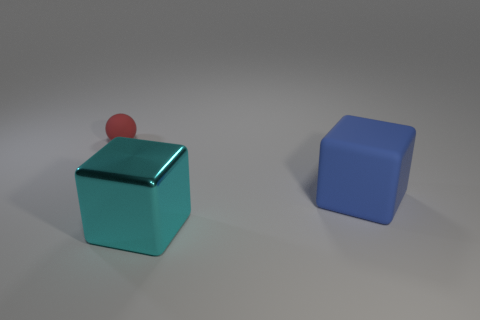Add 2 green matte objects. How many objects exist? 5 Subtract 1 spheres. How many spheres are left? 0 Subtract all balls. How many objects are left? 2 Subtract all yellow cylinders. How many yellow spheres are left? 0 Subtract all big blue matte cubes. Subtract all large cyan rubber things. How many objects are left? 2 Add 2 big cyan cubes. How many big cyan cubes are left? 3 Add 2 shiny blocks. How many shiny blocks exist? 3 Subtract all cyan blocks. How many blocks are left? 1 Subtract 0 gray balls. How many objects are left? 3 Subtract all purple cubes. Subtract all green cylinders. How many cubes are left? 2 